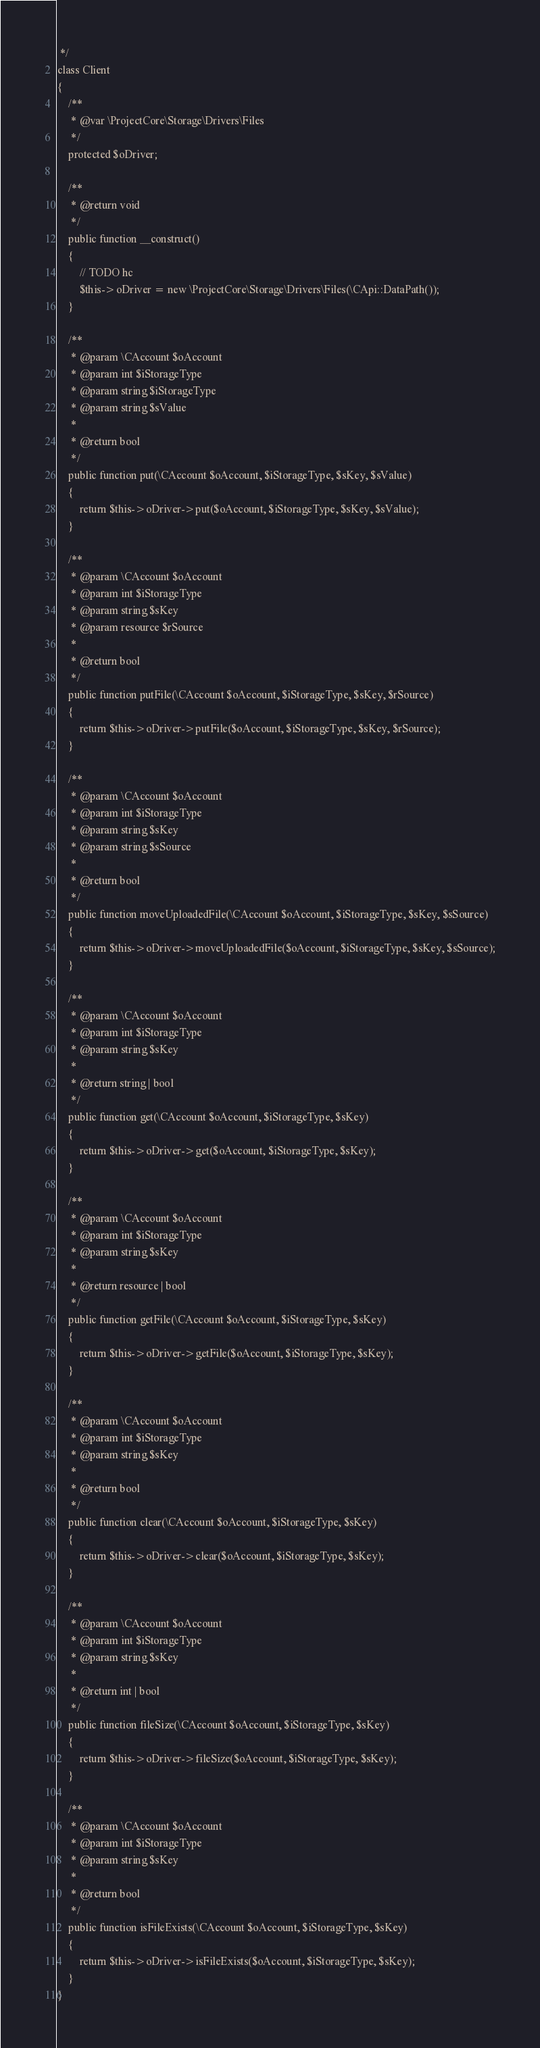Convert code to text. <code><loc_0><loc_0><loc_500><loc_500><_PHP_> */
class Client
{
	/**
	 * @var \ProjectCore\Storage\Drivers\Files
	 */
	protected $oDriver;

	/**
	 * @return void
	 */
	public function __construct()
	{
		// TODO hc
		$this->oDriver = new \ProjectCore\Storage\Drivers\Files(\CApi::DataPath());
	}

	/**
	 * @param \CAccount $oAccount
	 * @param int $iStorageType
	 * @param string $iStorageType
	 * @param string $sValue
	 *
	 * @return bool
	 */
	public function put(\CAccount $oAccount, $iStorageType, $sKey, $sValue)
	{
		return $this->oDriver->put($oAccount, $iStorageType, $sKey, $sValue);
	}

	/**
	 * @param \CAccount $oAccount
	 * @param int $iStorageType
	 * @param string $sKey
	 * @param resource $rSource
	 *
	 * @return bool
	 */
	public function putFile(\CAccount $oAccount, $iStorageType, $sKey, $rSource)
	{
		return $this->oDriver->putFile($oAccount, $iStorageType, $sKey, $rSource);
	}

	/**
	 * @param \CAccount $oAccount
	 * @param int $iStorageType
	 * @param string $sKey
	 * @param string $sSource
	 *
	 * @return bool
	 */
	public function moveUploadedFile(\CAccount $oAccount, $iStorageType, $sKey, $sSource)
	{
		return $this->oDriver->moveUploadedFile($oAccount, $iStorageType, $sKey, $sSource);
	}

	/**
	 * @param \CAccount $oAccount
	 * @param int $iStorageType
	 * @param string $sKey
	 *
	 * @return string | bool
	 */
	public function get(\CAccount $oAccount, $iStorageType, $sKey)
	{
		return $this->oDriver->get($oAccount, $iStorageType, $sKey);
	}

	/**
	 * @param \CAccount $oAccount
	 * @param int $iStorageType
	 * @param string $sKey
	 *
	 * @return resource | bool
	 */
	public function getFile(\CAccount $oAccount, $iStorageType, $sKey)
	{
		return $this->oDriver->getFile($oAccount, $iStorageType, $sKey);
	}

	/**
	 * @param \CAccount $oAccount
	 * @param int $iStorageType
	 * @param string $sKey
	 *
	 * @return bool
	 */
	public function clear(\CAccount $oAccount, $iStorageType, $sKey)
	{
		return $this->oDriver->clear($oAccount, $iStorageType, $sKey);
	}

	/**
	 * @param \CAccount $oAccount
	 * @param int $iStorageType
	 * @param string $sKey
	 *
	 * @return int | bool
	 */
	public function fileSize(\CAccount $oAccount, $iStorageType, $sKey)
	{
		return $this->oDriver->fileSize($oAccount, $iStorageType, $sKey);
	}

	/**
	 * @param \CAccount $oAccount
	 * @param int $iStorageType
	 * @param string $sKey
	 *
	 * @return bool
	 */
	public function isFileExists(\CAccount $oAccount, $iStorageType, $sKey)
	{
		return $this->oDriver->isFileExists($oAccount, $iStorageType, $sKey);
	}
}
</code> 